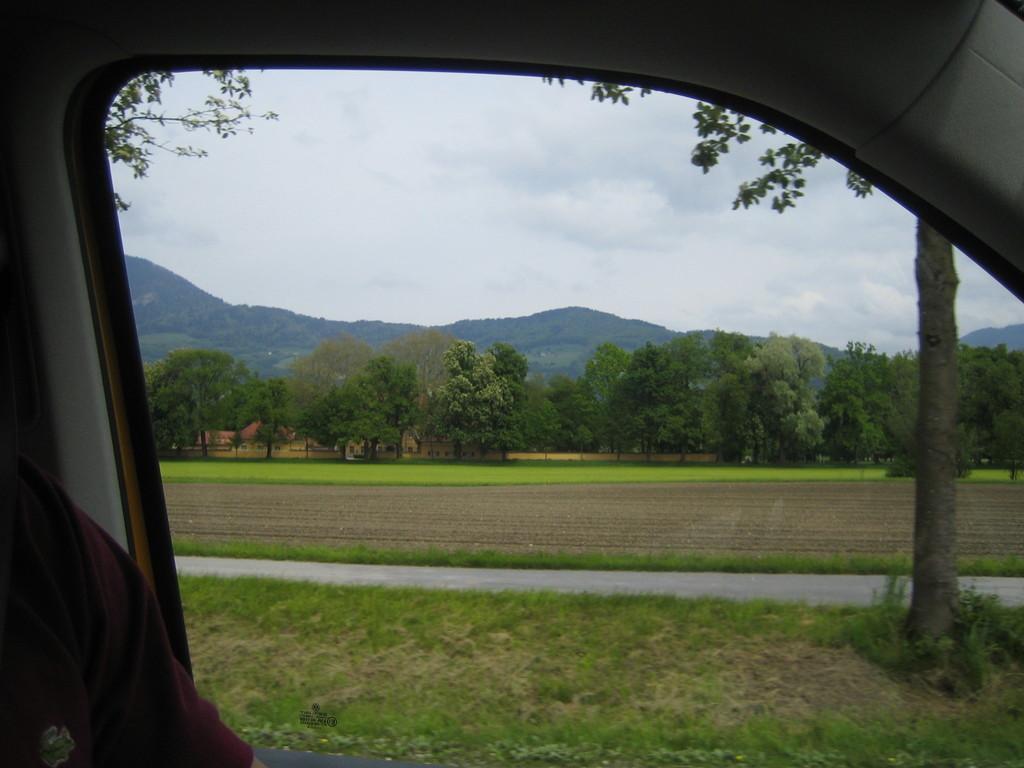In one or two sentences, can you explain what this image depicts? In the image we can see the window of the vehicle. Out of the window we can see grass, road, trees, hills and the cloudy sky. 